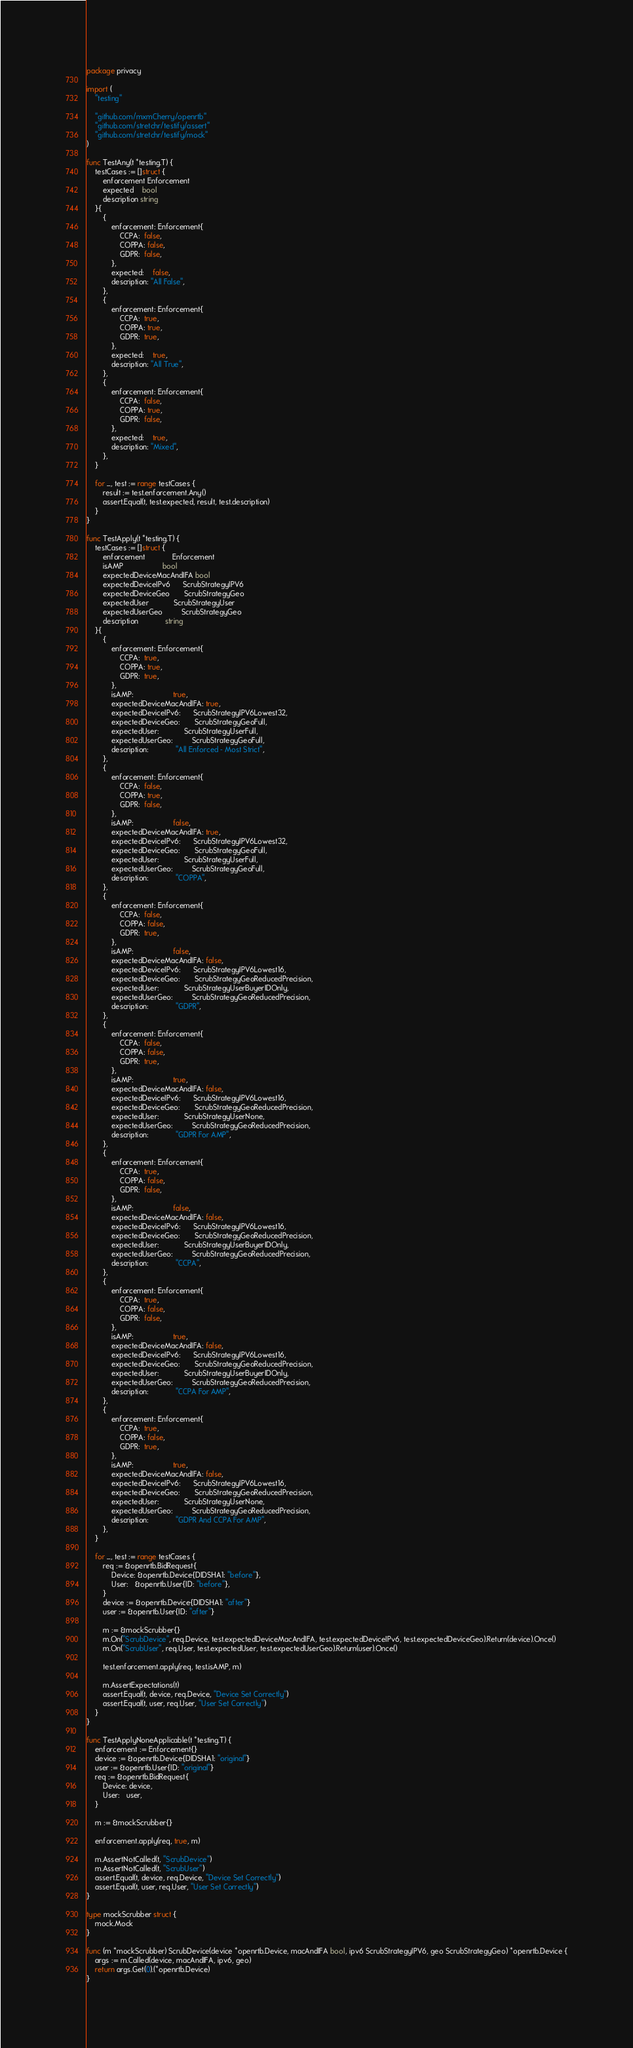<code> <loc_0><loc_0><loc_500><loc_500><_Go_>package privacy

import (
	"testing"

	"github.com/mxmCherry/openrtb"
	"github.com/stretchr/testify/assert"
	"github.com/stretchr/testify/mock"
)

func TestAny(t *testing.T) {
	testCases := []struct {
		enforcement Enforcement
		expected    bool
		description string
	}{
		{
			enforcement: Enforcement{
				CCPA:  false,
				COPPA: false,
				GDPR:  false,
			},
			expected:    false,
			description: "All False",
		},
		{
			enforcement: Enforcement{
				CCPA:  true,
				COPPA: true,
				GDPR:  true,
			},
			expected:    true,
			description: "All True",
		},
		{
			enforcement: Enforcement{
				CCPA:  false,
				COPPA: true,
				GDPR:  false,
			},
			expected:    true,
			description: "Mixed",
		},
	}

	for _, test := range testCases {
		result := test.enforcement.Any()
		assert.Equal(t, test.expected, result, test.description)
	}
}

func TestApply(t *testing.T) {
	testCases := []struct {
		enforcement             Enforcement
		isAMP                   bool
		expectedDeviceMacAndIFA bool
		expectedDeviceIPv6      ScrubStrategyIPV6
		expectedDeviceGeo       ScrubStrategyGeo
		expectedUser            ScrubStrategyUser
		expectedUserGeo         ScrubStrategyGeo
		description             string
	}{
		{
			enforcement: Enforcement{
				CCPA:  true,
				COPPA: true,
				GDPR:  true,
			},
			isAMP:                   true,
			expectedDeviceMacAndIFA: true,
			expectedDeviceIPv6:      ScrubStrategyIPV6Lowest32,
			expectedDeviceGeo:       ScrubStrategyGeoFull,
			expectedUser:            ScrubStrategyUserFull,
			expectedUserGeo:         ScrubStrategyGeoFull,
			description:             "All Enforced - Most Strict",
		},
		{
			enforcement: Enforcement{
				CCPA:  false,
				COPPA: true,
				GDPR:  false,
			},
			isAMP:                   false,
			expectedDeviceMacAndIFA: true,
			expectedDeviceIPv6:      ScrubStrategyIPV6Lowest32,
			expectedDeviceGeo:       ScrubStrategyGeoFull,
			expectedUser:            ScrubStrategyUserFull,
			expectedUserGeo:         ScrubStrategyGeoFull,
			description:             "COPPA",
		},
		{
			enforcement: Enforcement{
				CCPA:  false,
				COPPA: false,
				GDPR:  true,
			},
			isAMP:                   false,
			expectedDeviceMacAndIFA: false,
			expectedDeviceIPv6:      ScrubStrategyIPV6Lowest16,
			expectedDeviceGeo:       ScrubStrategyGeoReducedPrecision,
			expectedUser:            ScrubStrategyUserBuyerIDOnly,
			expectedUserGeo:         ScrubStrategyGeoReducedPrecision,
			description:             "GDPR",
		},
		{
			enforcement: Enforcement{
				CCPA:  false,
				COPPA: false,
				GDPR:  true,
			},
			isAMP:                   true,
			expectedDeviceMacAndIFA: false,
			expectedDeviceIPv6:      ScrubStrategyIPV6Lowest16,
			expectedDeviceGeo:       ScrubStrategyGeoReducedPrecision,
			expectedUser:            ScrubStrategyUserNone,
			expectedUserGeo:         ScrubStrategyGeoReducedPrecision,
			description:             "GDPR For AMP",
		},
		{
			enforcement: Enforcement{
				CCPA:  true,
				COPPA: false,
				GDPR:  false,
			},
			isAMP:                   false,
			expectedDeviceMacAndIFA: false,
			expectedDeviceIPv6:      ScrubStrategyIPV6Lowest16,
			expectedDeviceGeo:       ScrubStrategyGeoReducedPrecision,
			expectedUser:            ScrubStrategyUserBuyerIDOnly,
			expectedUserGeo:         ScrubStrategyGeoReducedPrecision,
			description:             "CCPA",
		},
		{
			enforcement: Enforcement{
				CCPA:  true,
				COPPA: false,
				GDPR:  false,
			},
			isAMP:                   true,
			expectedDeviceMacAndIFA: false,
			expectedDeviceIPv6:      ScrubStrategyIPV6Lowest16,
			expectedDeviceGeo:       ScrubStrategyGeoReducedPrecision,
			expectedUser:            ScrubStrategyUserBuyerIDOnly,
			expectedUserGeo:         ScrubStrategyGeoReducedPrecision,
			description:             "CCPA For AMP",
		},
		{
			enforcement: Enforcement{
				CCPA:  true,
				COPPA: false,
				GDPR:  true,
			},
			isAMP:                   true,
			expectedDeviceMacAndIFA: false,
			expectedDeviceIPv6:      ScrubStrategyIPV6Lowest16,
			expectedDeviceGeo:       ScrubStrategyGeoReducedPrecision,
			expectedUser:            ScrubStrategyUserNone,
			expectedUserGeo:         ScrubStrategyGeoReducedPrecision,
			description:             "GDPR And CCPA For AMP",
		},
	}

	for _, test := range testCases {
		req := &openrtb.BidRequest{
			Device: &openrtb.Device{DIDSHA1: "before"},
			User:   &openrtb.User{ID: "before"},
		}
		device := &openrtb.Device{DIDSHA1: "after"}
		user := &openrtb.User{ID: "after"}

		m := &mockScrubber{}
		m.On("ScrubDevice", req.Device, test.expectedDeviceMacAndIFA, test.expectedDeviceIPv6, test.expectedDeviceGeo).Return(device).Once()
		m.On("ScrubUser", req.User, test.expectedUser, test.expectedUserGeo).Return(user).Once()

		test.enforcement.apply(req, test.isAMP, m)

		m.AssertExpectations(t)
		assert.Equal(t, device, req.Device, "Device Set Correctly")
		assert.Equal(t, user, req.User, "User Set Correctly")
	}
}

func TestApplyNoneApplicable(t *testing.T) {
	enforcement := Enforcement{}
	device := &openrtb.Device{DIDSHA1: "original"}
	user := &openrtb.User{ID: "original"}
	req := &openrtb.BidRequest{
		Device: device,
		User:   user,
	}

	m := &mockScrubber{}

	enforcement.apply(req, true, m)

	m.AssertNotCalled(t, "ScrubDevice")
	m.AssertNotCalled(t, "ScrubUser")
	assert.Equal(t, device, req.Device, "Device Set Correctly")
	assert.Equal(t, user, req.User, "User Set Correctly")
}

type mockScrubber struct {
	mock.Mock
}

func (m *mockScrubber) ScrubDevice(device *openrtb.Device, macAndIFA bool, ipv6 ScrubStrategyIPV6, geo ScrubStrategyGeo) *openrtb.Device {
	args := m.Called(device, macAndIFA, ipv6, geo)
	return args.Get(0).(*openrtb.Device)
}
</code> 